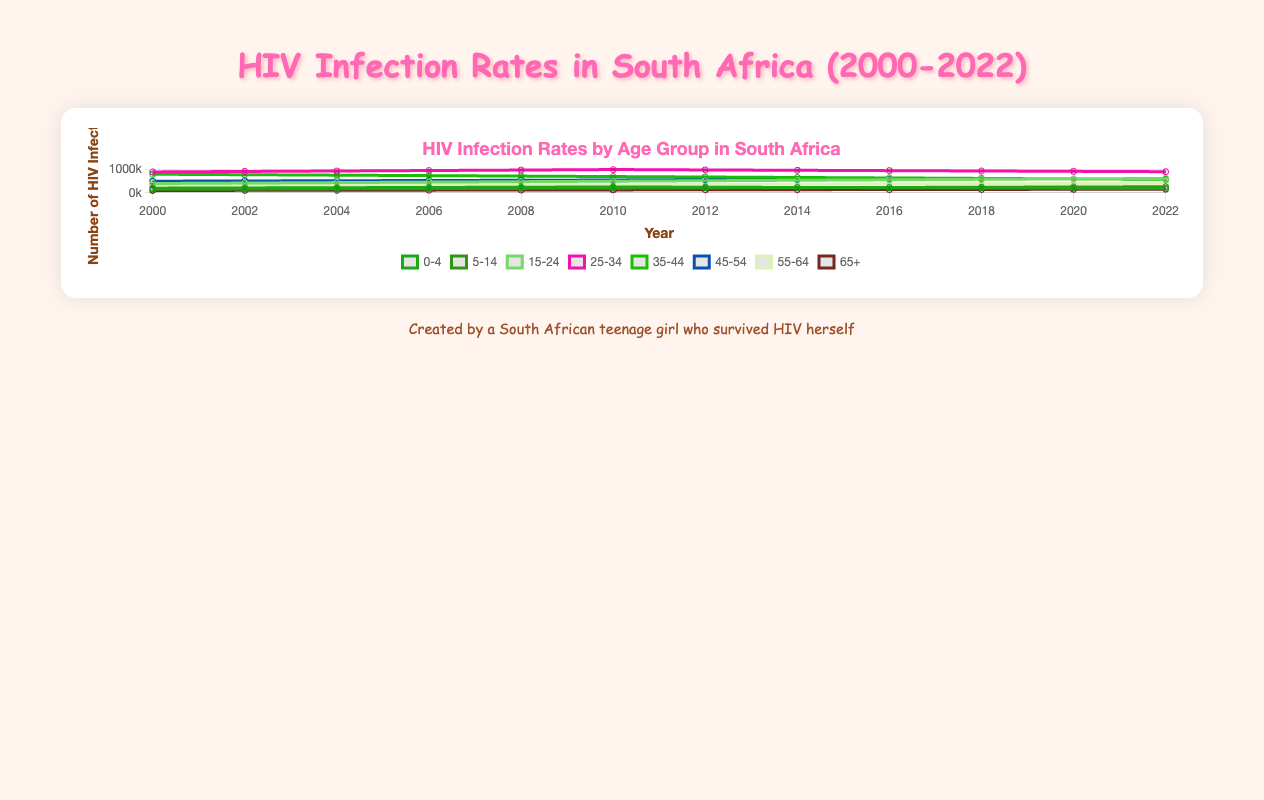How did the infection rate change for the age group "0-4" from 2000 to 2022? The infection rate for the age group "0-4" was 200,000 in 2000 and 190,000 in 2022, showing a decrease.
Answer: Decreased Which age group had the highest infection rate in 2010? In 2010, the age group "25-34" had the highest infection rate with 1,000,000 infections.
Answer: 25-34 What is the average number of infections for the age group "15-24" across all years? Sum the infection rates for "15-24" across all years and divide by the number of data points: (400,000 + 420,000 + 440,000 + 460,000 + 480,000 + 500,000 + 520,000 + 540,000 + 560,000 + 580,000 + 600,000 + 620,000) / 12 = 484,166.67
Answer: 484,166.67 Did the infection rate for "25-34" always remain higher than "35-44" from 2000 to 2022? By comparing the infection rates for "25-34" and "35-44" for each year, we see that "25-34" always had higher rates than "35-44".
Answer: Yes How did the infection rate for the age group "65+" change from 2010 to 2022? In 2010, the rate was 125,000, and in 2022, it was 155,000, showing an increase.
Answer: Increased Which age group saw the most significant increase in infection rate between 2000 and 2022? Comparing the difference in numbers: "5-14" increased by 110,000 (150,000 to 260,000), which is the highest increase among the age groups.
Answer: 5-14 What was the total number of infections in 2016? Sum the infections for all age groups in 2016: 220,000 + 230,000 + 560,000 + 955,000 + 640,000 + 580,000 + 380,000 + 140,000 = 3,705,000
Answer: 3,705,000 Which age group had the smallest change in infection rates between 2000 and 2022? The age group "5-14" changed from 150,000 to 260,000, resulting in the smallest change of 110,000 compared to other groups.
Answer: 5-14 In what year did the "0-4" age group have the highest infection rate? The "0-4" age group had their highest infection rate in 2010, with 250,000 infections.
Answer: 2010 